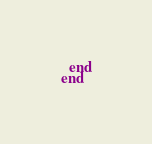Convert code to text. <code><loc_0><loc_0><loc_500><loc_500><_Ruby_>  end
end
</code> 